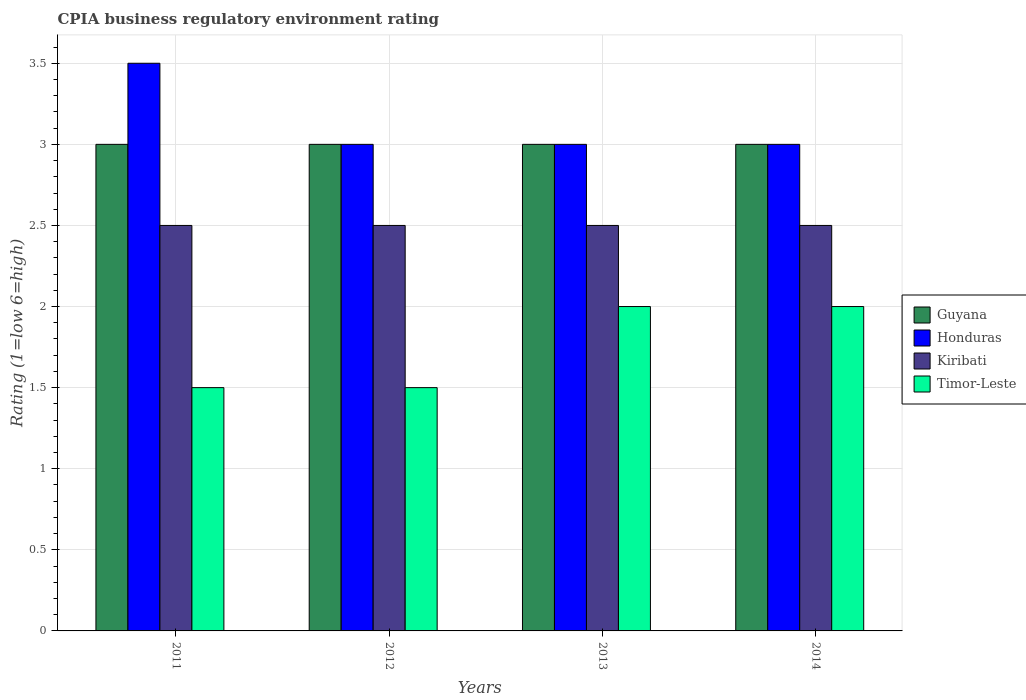How many bars are there on the 4th tick from the right?
Offer a terse response. 4. In how many cases, is the number of bars for a given year not equal to the number of legend labels?
Keep it short and to the point. 0. Across all years, what is the maximum CPIA rating in Kiribati?
Provide a short and direct response. 2.5. Across all years, what is the minimum CPIA rating in Honduras?
Provide a succinct answer. 3. In which year was the CPIA rating in Guyana maximum?
Offer a very short reply. 2011. In which year was the CPIA rating in Kiribati minimum?
Offer a terse response. 2011. What is the total CPIA rating in Guyana in the graph?
Provide a short and direct response. 12. What is the difference between the CPIA rating in Timor-Leste in 2012 and the CPIA rating in Kiribati in 2013?
Offer a very short reply. -1. What is the average CPIA rating in Guyana per year?
Give a very brief answer. 3. Is the CPIA rating in Timor-Leste in 2011 less than that in 2013?
Keep it short and to the point. Yes. In how many years, is the CPIA rating in Kiribati greater than the average CPIA rating in Kiribati taken over all years?
Give a very brief answer. 0. What does the 1st bar from the left in 2012 represents?
Your answer should be compact. Guyana. What does the 2nd bar from the right in 2011 represents?
Offer a very short reply. Kiribati. How many bars are there?
Your response must be concise. 16. Are all the bars in the graph horizontal?
Provide a short and direct response. No. How many years are there in the graph?
Offer a very short reply. 4. Does the graph contain any zero values?
Ensure brevity in your answer.  No. Does the graph contain grids?
Provide a short and direct response. Yes. Where does the legend appear in the graph?
Offer a terse response. Center right. What is the title of the graph?
Your answer should be very brief. CPIA business regulatory environment rating. Does "Nicaragua" appear as one of the legend labels in the graph?
Give a very brief answer. No. What is the Rating (1=low 6=high) of Guyana in 2011?
Provide a short and direct response. 3. What is the Rating (1=low 6=high) of Kiribati in 2011?
Keep it short and to the point. 2.5. What is the Rating (1=low 6=high) in Guyana in 2012?
Your answer should be very brief. 3. What is the Rating (1=low 6=high) in Timor-Leste in 2012?
Provide a short and direct response. 1.5. What is the Rating (1=low 6=high) in Guyana in 2013?
Ensure brevity in your answer.  3. What is the Rating (1=low 6=high) in Kiribati in 2013?
Your answer should be compact. 2.5. What is the Rating (1=low 6=high) of Guyana in 2014?
Your answer should be compact. 3. What is the Rating (1=low 6=high) in Kiribati in 2014?
Provide a succinct answer. 2.5. Across all years, what is the maximum Rating (1=low 6=high) in Guyana?
Your response must be concise. 3. Across all years, what is the maximum Rating (1=low 6=high) in Honduras?
Provide a succinct answer. 3.5. Across all years, what is the maximum Rating (1=low 6=high) of Timor-Leste?
Make the answer very short. 2. Across all years, what is the minimum Rating (1=low 6=high) of Honduras?
Offer a terse response. 3. Across all years, what is the minimum Rating (1=low 6=high) in Kiribati?
Offer a terse response. 2.5. Across all years, what is the minimum Rating (1=low 6=high) of Timor-Leste?
Your answer should be compact. 1.5. What is the difference between the Rating (1=low 6=high) of Guyana in 2011 and that in 2012?
Make the answer very short. 0. What is the difference between the Rating (1=low 6=high) in Kiribati in 2011 and that in 2012?
Your response must be concise. 0. What is the difference between the Rating (1=low 6=high) in Timor-Leste in 2011 and that in 2012?
Make the answer very short. 0. What is the difference between the Rating (1=low 6=high) in Timor-Leste in 2011 and that in 2013?
Your answer should be very brief. -0.5. What is the difference between the Rating (1=low 6=high) in Guyana in 2011 and that in 2014?
Make the answer very short. 0. What is the difference between the Rating (1=low 6=high) in Timor-Leste in 2012 and that in 2013?
Your response must be concise. -0.5. What is the difference between the Rating (1=low 6=high) in Timor-Leste in 2012 and that in 2014?
Provide a succinct answer. -0.5. What is the difference between the Rating (1=low 6=high) of Kiribati in 2013 and that in 2014?
Ensure brevity in your answer.  0. What is the difference between the Rating (1=low 6=high) in Guyana in 2011 and the Rating (1=low 6=high) in Kiribati in 2012?
Provide a succinct answer. 0.5. What is the difference between the Rating (1=low 6=high) of Honduras in 2011 and the Rating (1=low 6=high) of Kiribati in 2012?
Give a very brief answer. 1. What is the difference between the Rating (1=low 6=high) of Guyana in 2011 and the Rating (1=low 6=high) of Honduras in 2013?
Offer a terse response. 0. What is the difference between the Rating (1=low 6=high) of Guyana in 2011 and the Rating (1=low 6=high) of Kiribati in 2013?
Ensure brevity in your answer.  0.5. What is the difference between the Rating (1=low 6=high) of Guyana in 2011 and the Rating (1=low 6=high) of Timor-Leste in 2013?
Offer a terse response. 1. What is the difference between the Rating (1=low 6=high) of Honduras in 2011 and the Rating (1=low 6=high) of Timor-Leste in 2013?
Your answer should be compact. 1.5. What is the difference between the Rating (1=low 6=high) of Kiribati in 2011 and the Rating (1=low 6=high) of Timor-Leste in 2013?
Give a very brief answer. 0.5. What is the difference between the Rating (1=low 6=high) of Guyana in 2011 and the Rating (1=low 6=high) of Honduras in 2014?
Provide a short and direct response. 0. What is the difference between the Rating (1=low 6=high) of Kiribati in 2011 and the Rating (1=low 6=high) of Timor-Leste in 2014?
Provide a succinct answer. 0.5. What is the difference between the Rating (1=low 6=high) in Guyana in 2012 and the Rating (1=low 6=high) in Honduras in 2013?
Offer a very short reply. 0. What is the difference between the Rating (1=low 6=high) of Guyana in 2012 and the Rating (1=low 6=high) of Kiribati in 2013?
Provide a succinct answer. 0.5. What is the difference between the Rating (1=low 6=high) of Kiribati in 2012 and the Rating (1=low 6=high) of Timor-Leste in 2013?
Your response must be concise. 0.5. What is the difference between the Rating (1=low 6=high) of Guyana in 2012 and the Rating (1=low 6=high) of Kiribati in 2014?
Provide a succinct answer. 0.5. What is the difference between the Rating (1=low 6=high) in Guyana in 2012 and the Rating (1=low 6=high) in Timor-Leste in 2014?
Provide a short and direct response. 1. What is the difference between the Rating (1=low 6=high) of Kiribati in 2012 and the Rating (1=low 6=high) of Timor-Leste in 2014?
Provide a succinct answer. 0.5. What is the difference between the Rating (1=low 6=high) in Guyana in 2013 and the Rating (1=low 6=high) in Timor-Leste in 2014?
Your answer should be compact. 1. What is the difference between the Rating (1=low 6=high) of Honduras in 2013 and the Rating (1=low 6=high) of Kiribati in 2014?
Ensure brevity in your answer.  0.5. What is the difference between the Rating (1=low 6=high) of Kiribati in 2013 and the Rating (1=low 6=high) of Timor-Leste in 2014?
Your response must be concise. 0.5. What is the average Rating (1=low 6=high) of Honduras per year?
Make the answer very short. 3.12. In the year 2011, what is the difference between the Rating (1=low 6=high) of Guyana and Rating (1=low 6=high) of Honduras?
Your answer should be compact. -0.5. In the year 2011, what is the difference between the Rating (1=low 6=high) of Guyana and Rating (1=low 6=high) of Timor-Leste?
Provide a succinct answer. 1.5. In the year 2011, what is the difference between the Rating (1=low 6=high) of Kiribati and Rating (1=low 6=high) of Timor-Leste?
Keep it short and to the point. 1. In the year 2012, what is the difference between the Rating (1=low 6=high) of Guyana and Rating (1=low 6=high) of Honduras?
Your answer should be very brief. 0. In the year 2012, what is the difference between the Rating (1=low 6=high) of Guyana and Rating (1=low 6=high) of Kiribati?
Your answer should be very brief. 0.5. In the year 2012, what is the difference between the Rating (1=low 6=high) of Honduras and Rating (1=low 6=high) of Kiribati?
Provide a short and direct response. 0.5. In the year 2012, what is the difference between the Rating (1=low 6=high) of Honduras and Rating (1=low 6=high) of Timor-Leste?
Offer a terse response. 1.5. In the year 2013, what is the difference between the Rating (1=low 6=high) in Guyana and Rating (1=low 6=high) in Kiribati?
Offer a very short reply. 0.5. In the year 2013, what is the difference between the Rating (1=low 6=high) of Kiribati and Rating (1=low 6=high) of Timor-Leste?
Your response must be concise. 0.5. In the year 2014, what is the difference between the Rating (1=low 6=high) in Guyana and Rating (1=low 6=high) in Honduras?
Provide a succinct answer. 0. In the year 2014, what is the difference between the Rating (1=low 6=high) of Honduras and Rating (1=low 6=high) of Timor-Leste?
Keep it short and to the point. 1. In the year 2014, what is the difference between the Rating (1=low 6=high) of Kiribati and Rating (1=low 6=high) of Timor-Leste?
Keep it short and to the point. 0.5. What is the ratio of the Rating (1=low 6=high) in Honduras in 2011 to that in 2012?
Your answer should be compact. 1.17. What is the ratio of the Rating (1=low 6=high) of Honduras in 2011 to that in 2013?
Provide a short and direct response. 1.17. What is the ratio of the Rating (1=low 6=high) in Timor-Leste in 2011 to that in 2013?
Your answer should be compact. 0.75. What is the ratio of the Rating (1=low 6=high) of Guyana in 2011 to that in 2014?
Offer a very short reply. 1. What is the ratio of the Rating (1=low 6=high) of Kiribati in 2011 to that in 2014?
Your answer should be compact. 1. What is the ratio of the Rating (1=low 6=high) in Guyana in 2012 to that in 2013?
Offer a terse response. 1. What is the ratio of the Rating (1=low 6=high) of Honduras in 2012 to that in 2013?
Your response must be concise. 1. What is the ratio of the Rating (1=low 6=high) of Honduras in 2012 to that in 2014?
Your answer should be very brief. 1. What is the ratio of the Rating (1=low 6=high) in Timor-Leste in 2012 to that in 2014?
Provide a succinct answer. 0.75. What is the ratio of the Rating (1=low 6=high) of Honduras in 2013 to that in 2014?
Give a very brief answer. 1. What is the difference between the highest and the second highest Rating (1=low 6=high) of Kiribati?
Provide a succinct answer. 0. What is the difference between the highest and the second highest Rating (1=low 6=high) of Timor-Leste?
Ensure brevity in your answer.  0. What is the difference between the highest and the lowest Rating (1=low 6=high) in Kiribati?
Your answer should be compact. 0. What is the difference between the highest and the lowest Rating (1=low 6=high) of Timor-Leste?
Your answer should be very brief. 0.5. 